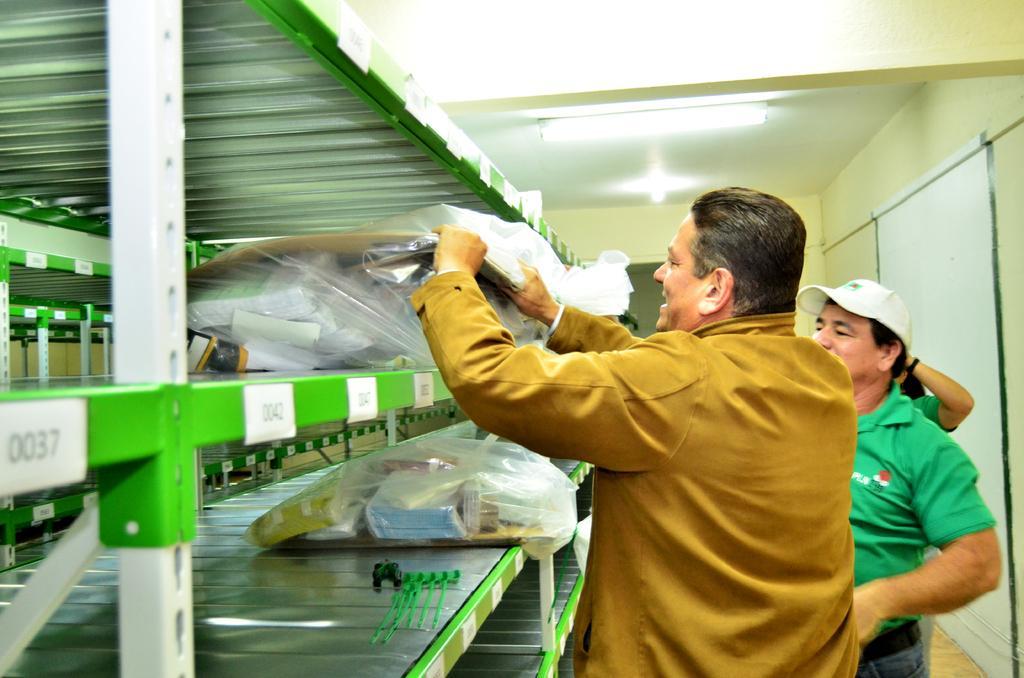In one or two sentences, can you explain what this image depicts? In the image there are persons standing in front of rack with things inside covers and there are lights over the ceiling, this is clicked inside a room. 